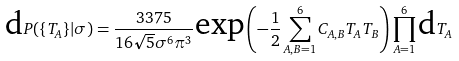<formula> <loc_0><loc_0><loc_500><loc_500>\text {d} P ( \{ T _ { A } \} | \sigma ) = \frac { 3 3 7 5 } { 1 6 \sqrt { 5 } \sigma ^ { 6 } \pi ^ { 3 } } \text {exp} \left ( - \frac { 1 } { 2 } \sum _ { A , B = 1 } ^ { 6 } C _ { A , B } T _ { A } T _ { B } \right ) \prod _ { A = 1 } ^ { 6 } \text {d} T _ { A }</formula> 